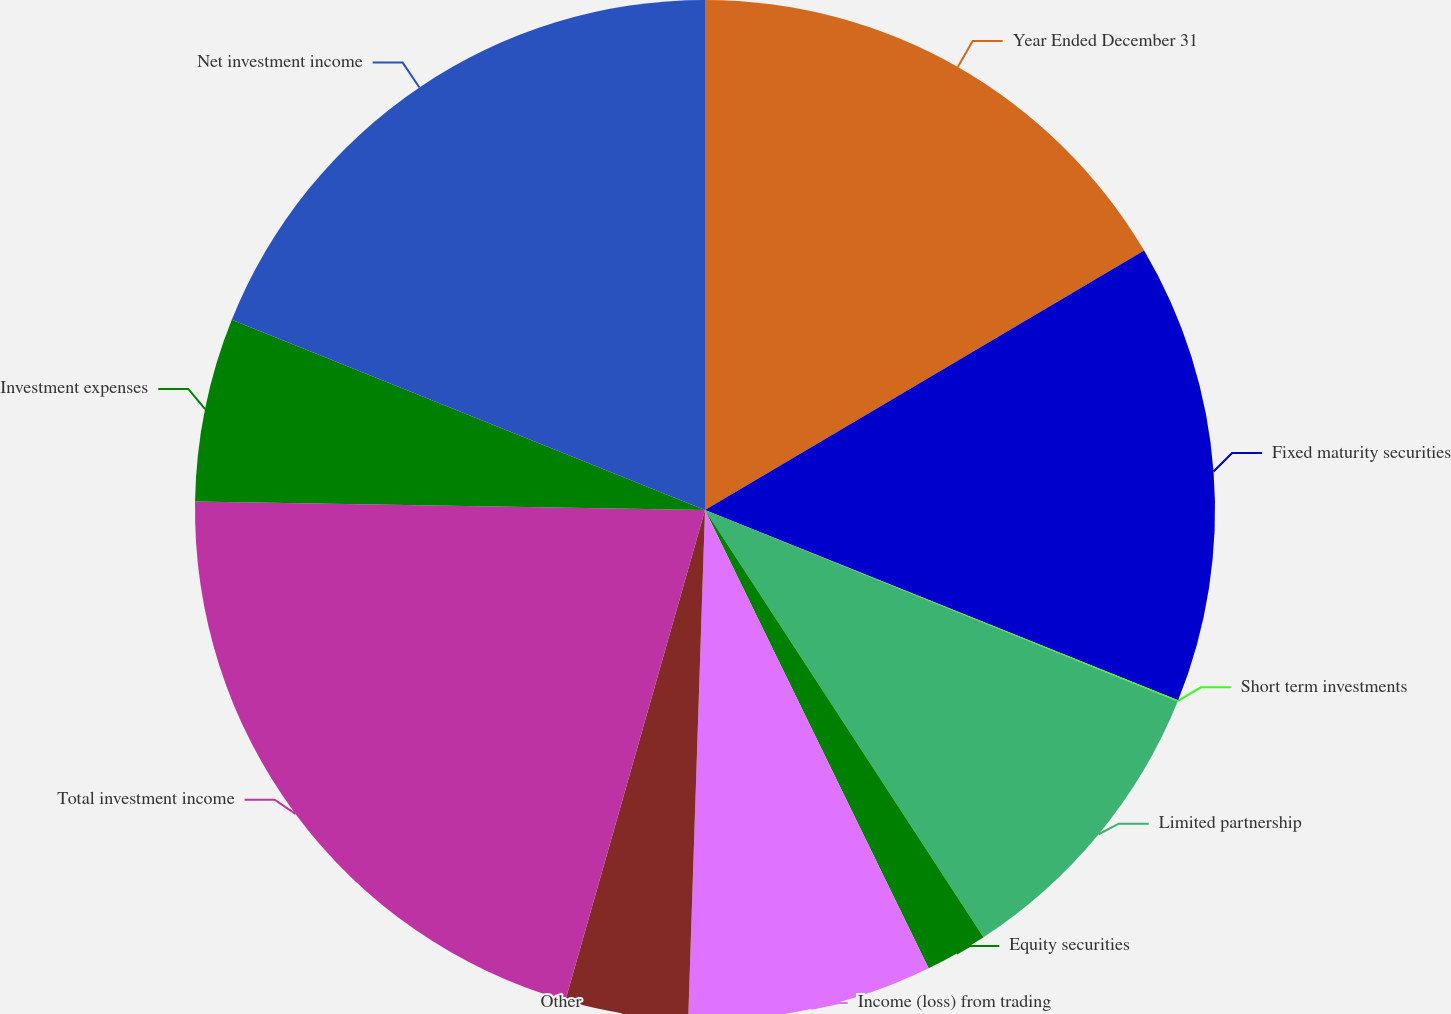<chart> <loc_0><loc_0><loc_500><loc_500><pie_chart><fcel>Year Ended December 31<fcel>Fixed maturity securities<fcel>Short term investments<fcel>Limited partnership<fcel>Equity securities<fcel>Income (loss) from trading<fcel>Other<fcel>Total investment income<fcel>Investment expenses<fcel>Net investment income<nl><fcel>16.51%<fcel>14.58%<fcel>0.04%<fcel>9.68%<fcel>1.97%<fcel>7.75%<fcel>3.89%<fcel>20.85%<fcel>5.82%<fcel>18.92%<nl></chart> 